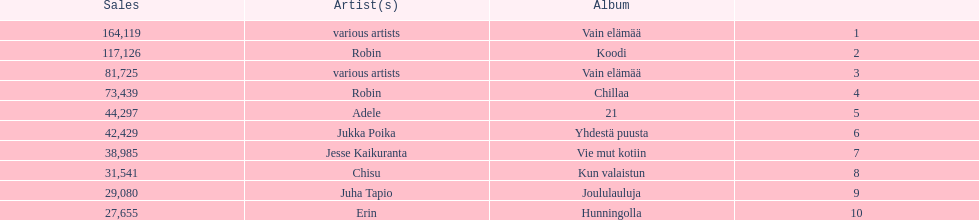Tell me an album that had the same artist as chillaa. Koodi. 